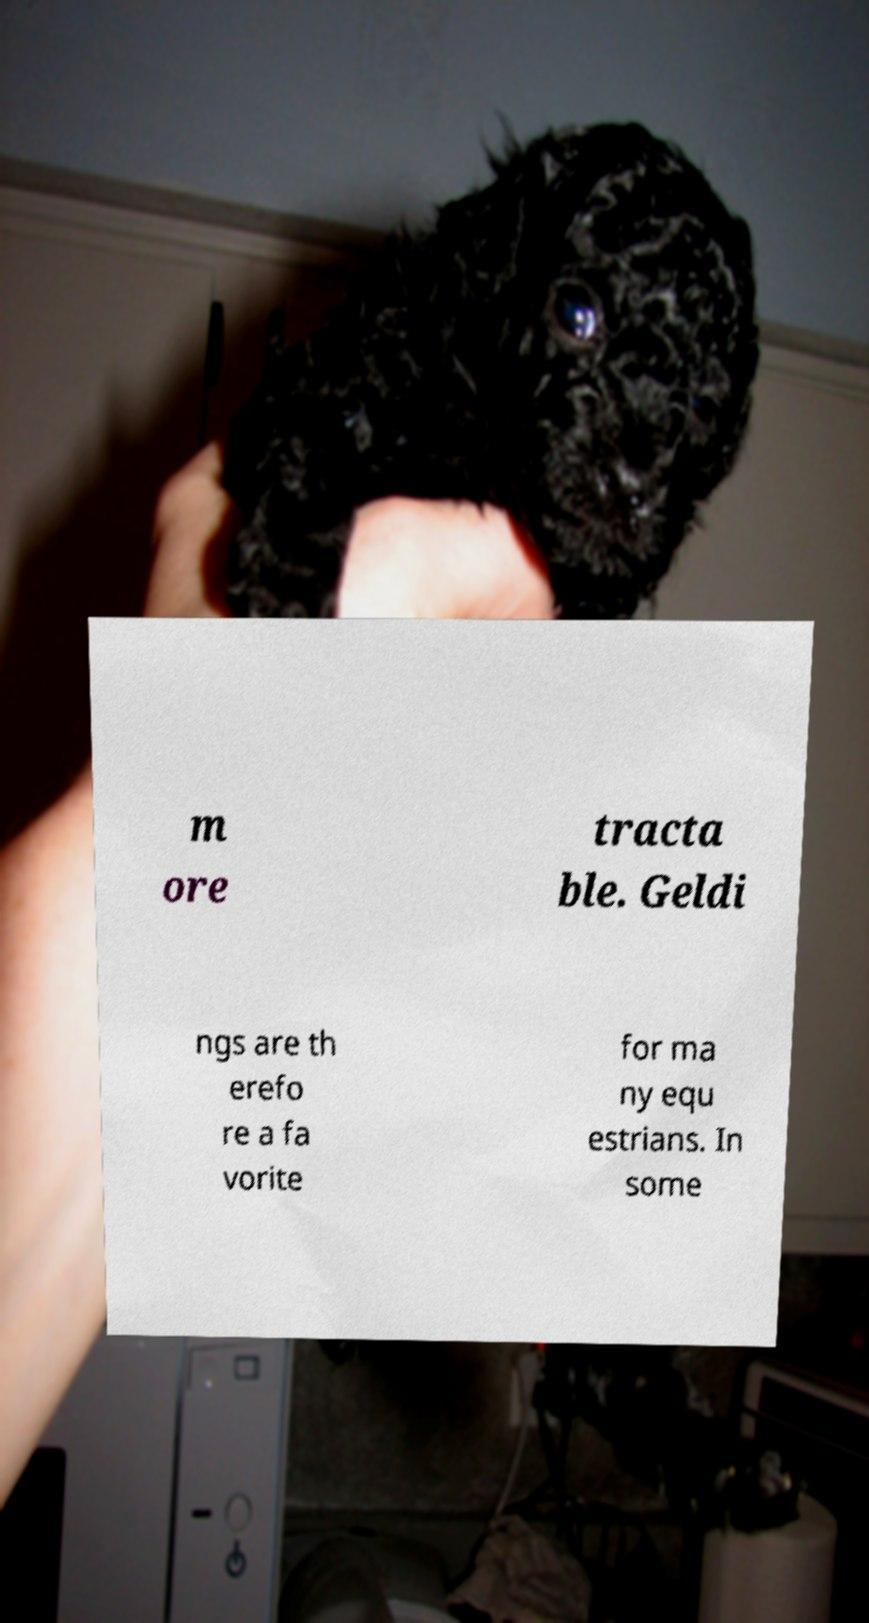Can you accurately transcribe the text from the provided image for me? m ore tracta ble. Geldi ngs are th erefo re a fa vorite for ma ny equ estrians. In some 